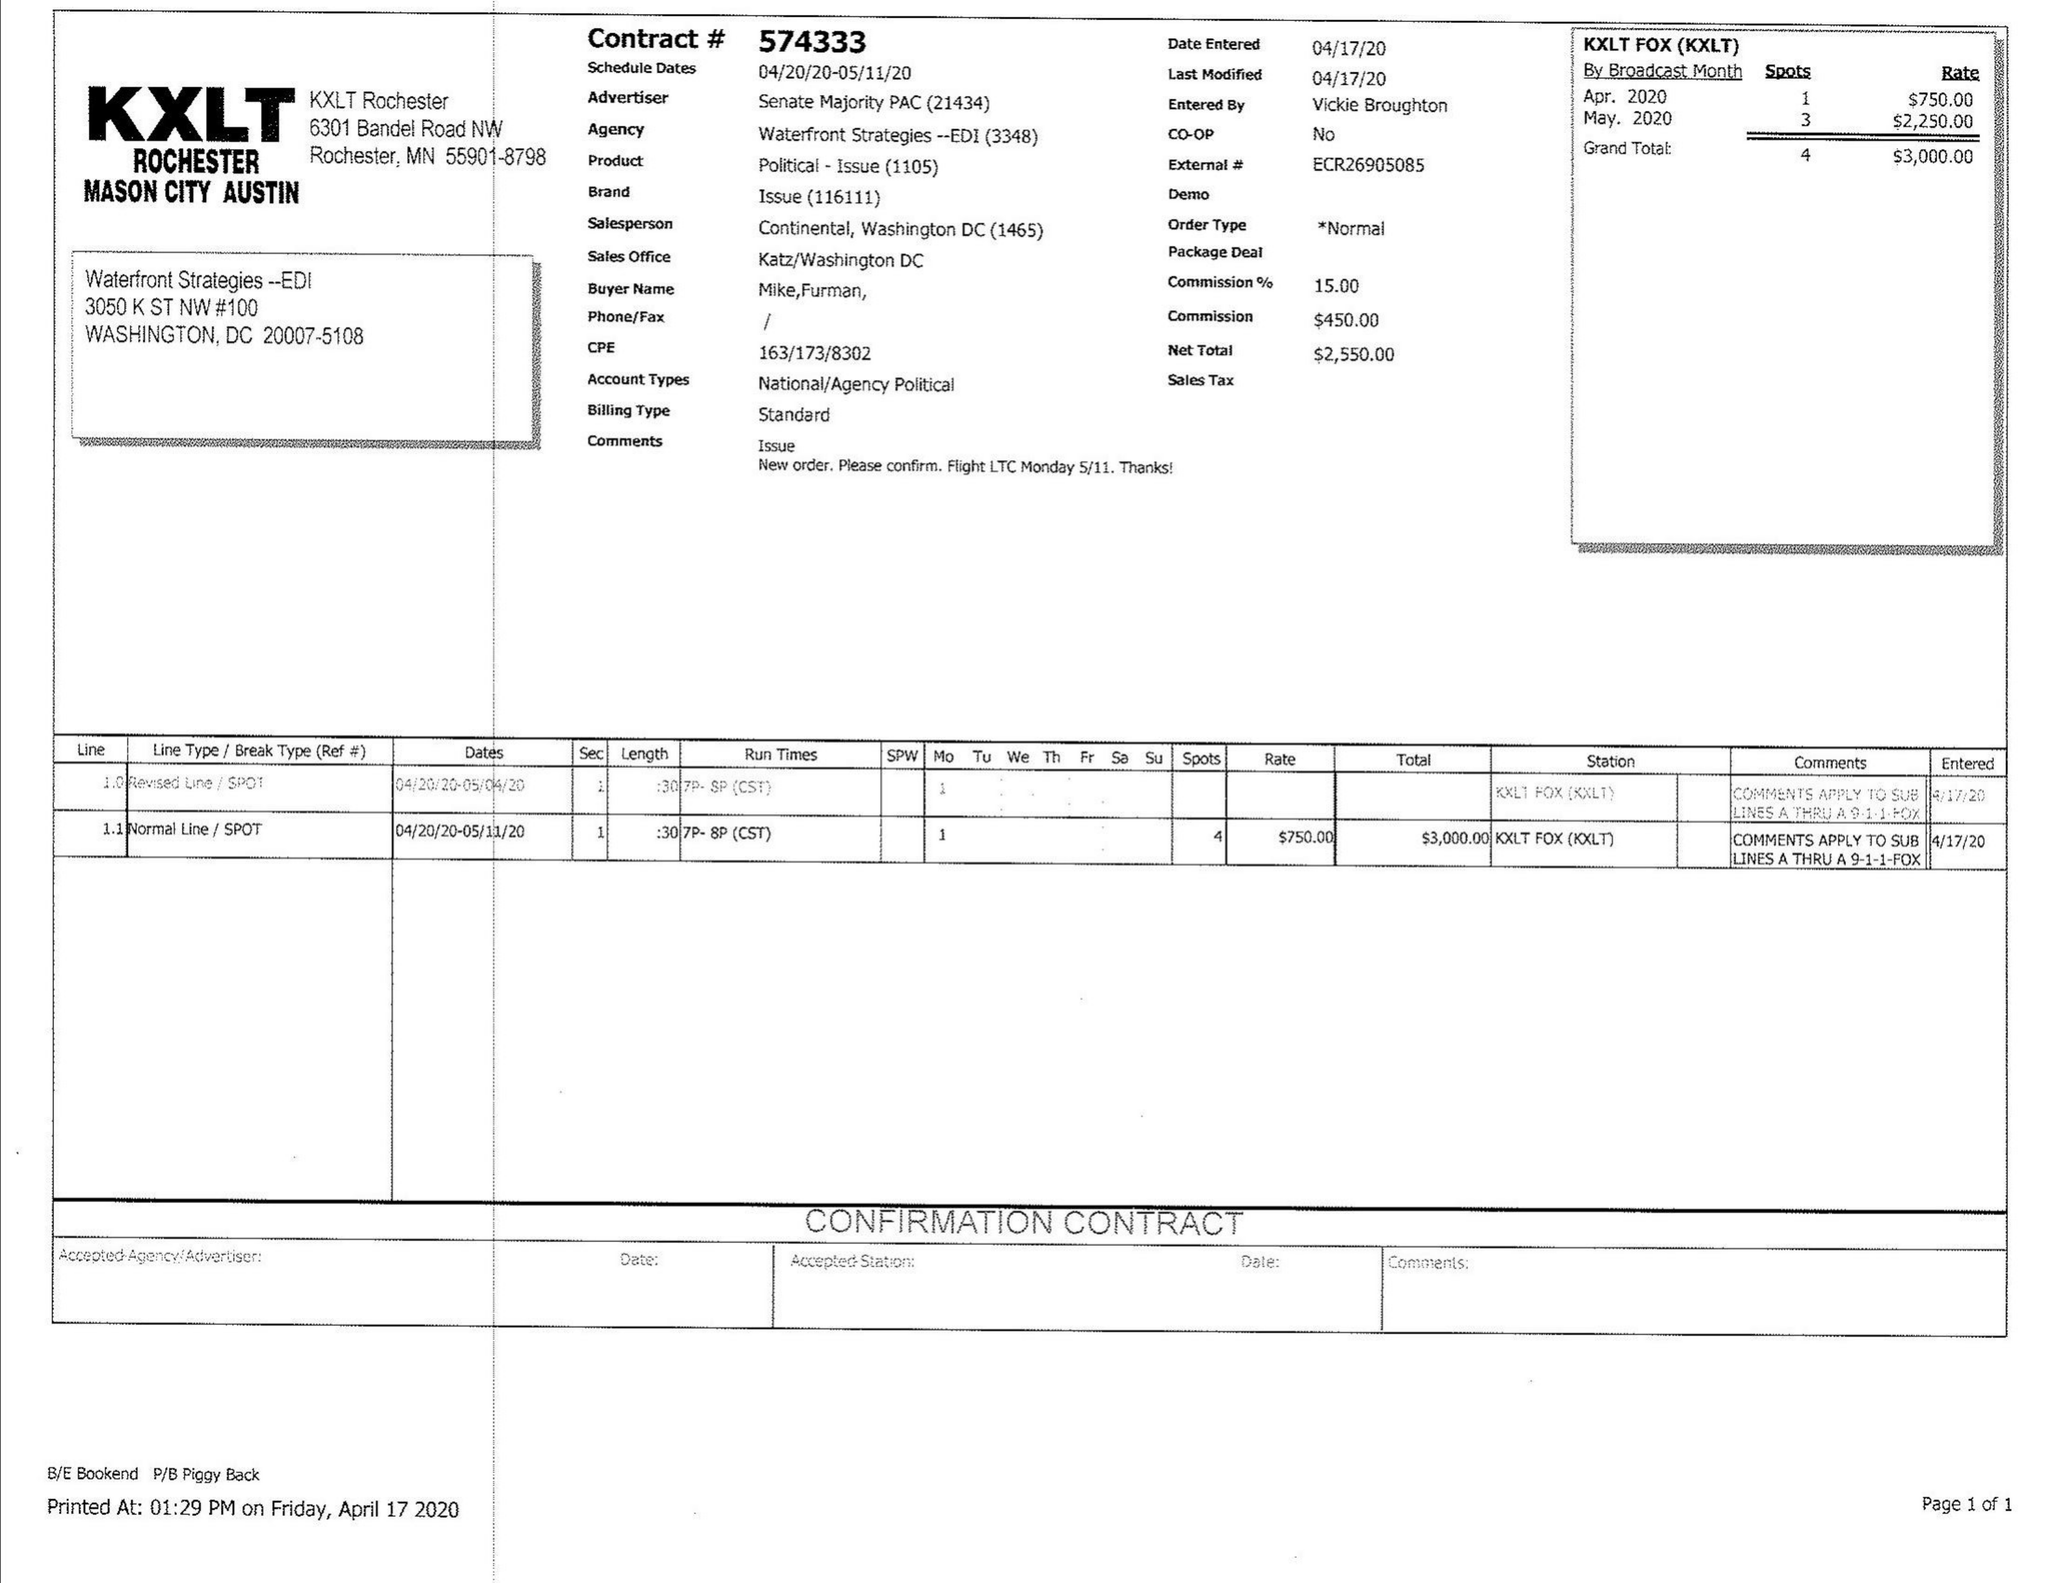What is the value for the advertiser?
Answer the question using a single word or phrase. SENATEMAJORITYPAC 